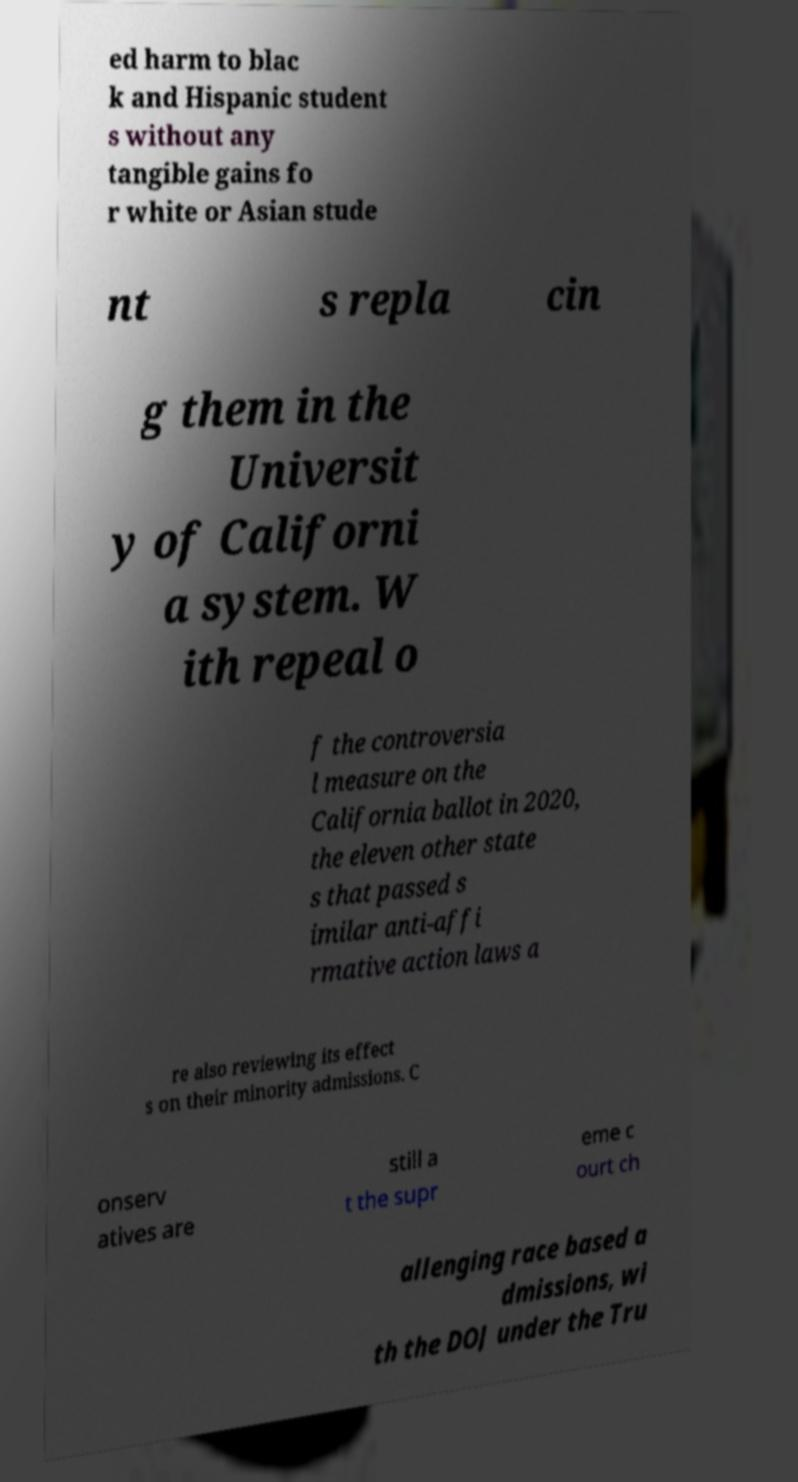For documentation purposes, I need the text within this image transcribed. Could you provide that? ed harm to blac k and Hispanic student s without any tangible gains fo r white or Asian stude nt s repla cin g them in the Universit y of Californi a system. W ith repeal o f the controversia l measure on the California ballot in 2020, the eleven other state s that passed s imilar anti-affi rmative action laws a re also reviewing its effect s on their minority admissions. C onserv atives are still a t the supr eme c ourt ch allenging race based a dmissions, wi th the DOJ under the Tru 